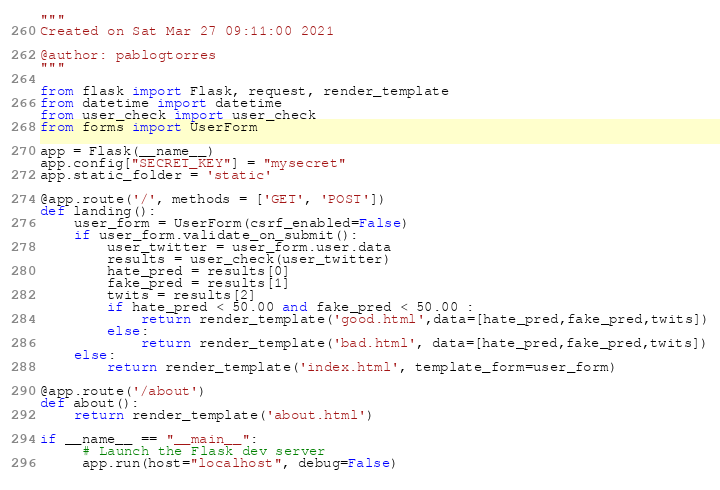<code> <loc_0><loc_0><loc_500><loc_500><_Python_>
"""
Created on Sat Mar 27 09:11:00 2021

@author: pablogtorres
"""

from flask import Flask, request, render_template
from datetime import datetime
from user_check import user_check
from forms import UserForm

app = Flask(__name__)
app.config["SECRET_KEY"] = "mysecret"
app.static_folder = 'static'

@app.route('/', methods = ['GET', 'POST'])
def landing():
    user_form = UserForm(csrf_enabled=False)
    if user_form.validate_on_submit():
        user_twitter = user_form.user.data
        results = user_check(user_twitter)
        hate_pred = results[0]
        fake_pred = results[1]
        twits = results[2]
        if hate_pred < 50.00 and fake_pred < 50.00 :
            return render_template('good.html',data=[hate_pred,fake_pred,twits])
        else:
            return render_template('bad.html', data=[hate_pred,fake_pred,twits])
    else:
        return render_template('index.html', template_form=user_form)

@app.route('/about')
def about():
    return render_template('about.html')

if __name__ == "__main__":
     # Launch the Flask dev server
     app.run(host="localhost", debug=False)
     
</code> 